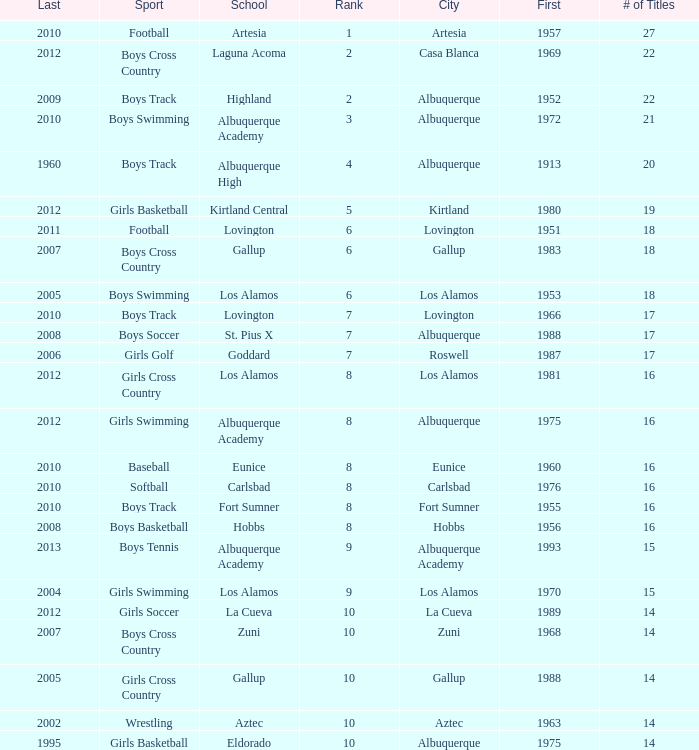Give me the full table as a dictionary. {'header': ['Last', 'Sport', 'School', 'Rank', 'City', 'First', '# of Titles'], 'rows': [['2010', 'Football', 'Artesia', '1', 'Artesia', '1957', '27'], ['2012', 'Boys Cross Country', 'Laguna Acoma', '2', 'Casa Blanca', '1969', '22'], ['2009', 'Boys Track', 'Highland', '2', 'Albuquerque', '1952', '22'], ['2010', 'Boys Swimming', 'Albuquerque Academy', '3', 'Albuquerque', '1972', '21'], ['1960', 'Boys Track', 'Albuquerque High', '4', 'Albuquerque', '1913', '20'], ['2012', 'Girls Basketball', 'Kirtland Central', '5', 'Kirtland', '1980', '19'], ['2011', 'Football', 'Lovington', '6', 'Lovington', '1951', '18'], ['2007', 'Boys Cross Country', 'Gallup', '6', 'Gallup', '1983', '18'], ['2005', 'Boys Swimming', 'Los Alamos', '6', 'Los Alamos', '1953', '18'], ['2010', 'Boys Track', 'Lovington', '7', 'Lovington', '1966', '17'], ['2008', 'Boys Soccer', 'St. Pius X', '7', 'Albuquerque', '1988', '17'], ['2006', 'Girls Golf', 'Goddard', '7', 'Roswell', '1987', '17'], ['2012', 'Girls Cross Country', 'Los Alamos', '8', 'Los Alamos', '1981', '16'], ['2012', 'Girls Swimming', 'Albuquerque Academy', '8', 'Albuquerque', '1975', '16'], ['2010', 'Baseball', 'Eunice', '8', 'Eunice', '1960', '16'], ['2010', 'Softball', 'Carlsbad', '8', 'Carlsbad', '1976', '16'], ['2010', 'Boys Track', 'Fort Sumner', '8', 'Fort Sumner', '1955', '16'], ['2008', 'Boys Basketball', 'Hobbs', '8', 'Hobbs', '1956', '16'], ['2013', 'Boys Tennis', 'Albuquerque Academy', '9', 'Albuquerque Academy', '1993', '15'], ['2004', 'Girls Swimming', 'Los Alamos', '9', 'Los Alamos', '1970', '15'], ['2012', 'Girls Soccer', 'La Cueva', '10', 'La Cueva', '1989', '14'], ['2007', 'Boys Cross Country', 'Zuni', '10', 'Zuni', '1968', '14'], ['2005', 'Girls Cross Country', 'Gallup', '10', 'Gallup', '1988', '14'], ['2002', 'Wrestling', 'Aztec', '10', 'Aztec', '1963', '14'], ['1995', 'Girls Basketball', 'Eldorado', '10', 'Albuquerque', '1975', '14']]} What is the highest rank for the boys swimming team in Albuquerque? 3.0. 